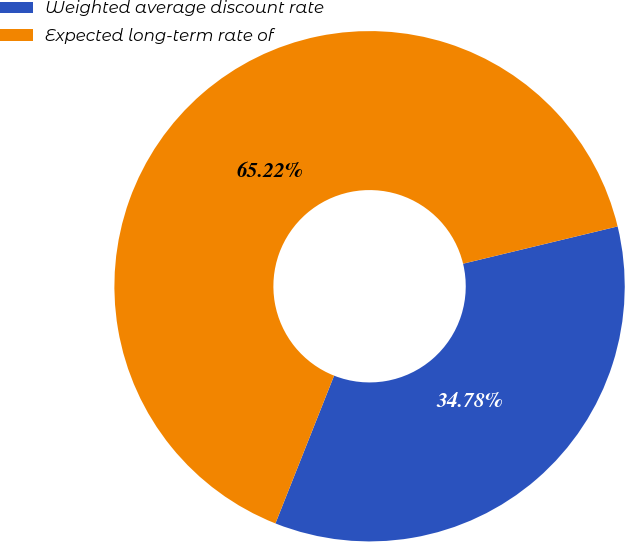Convert chart to OTSL. <chart><loc_0><loc_0><loc_500><loc_500><pie_chart><fcel>Weighted average discount rate<fcel>Expected long-term rate of<nl><fcel>34.78%<fcel>65.22%<nl></chart> 